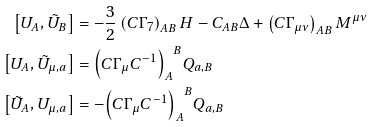<formula> <loc_0><loc_0><loc_500><loc_500>\left [ U _ { A } , \tilde { U } _ { B } \right ] & = - \frac { 3 } { 2 } \left ( C \Gamma _ { 7 } \right ) _ { A B } H - C _ { A B } \Delta + \left ( C \Gamma _ { \mu \nu } \right ) _ { A B } M ^ { \mu \nu } \\ \left [ U _ { A } , \tilde { U } _ { \mu , a } \right ] & = { \left ( C \Gamma _ { \mu } C ^ { - 1 } \right ) _ { A } } ^ { B } Q _ { a , B } \\ \left [ \tilde { U } _ { A } , U _ { \mu , a } \right ] & = - { \left ( C \Gamma _ { \mu } C ^ { - 1 } \right ) _ { A } } ^ { B } Q _ { a , B }</formula> 